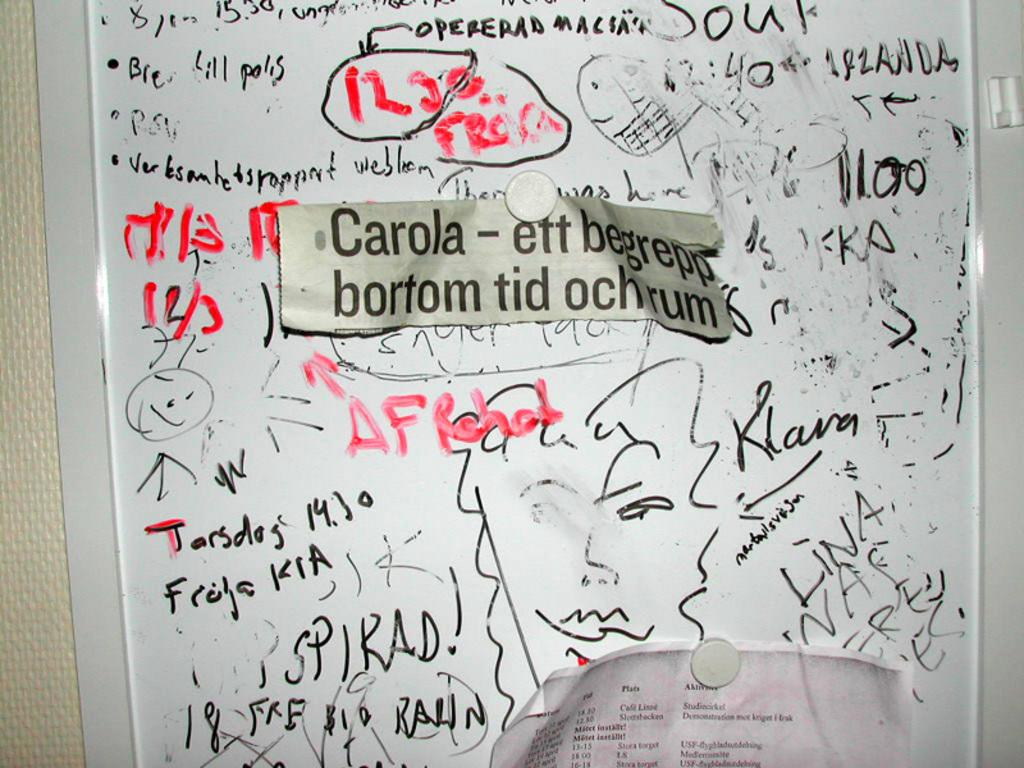<image>
Summarize the visual content of the image. A newspaper headline that says Carola on it hangs on a whiteboard. 